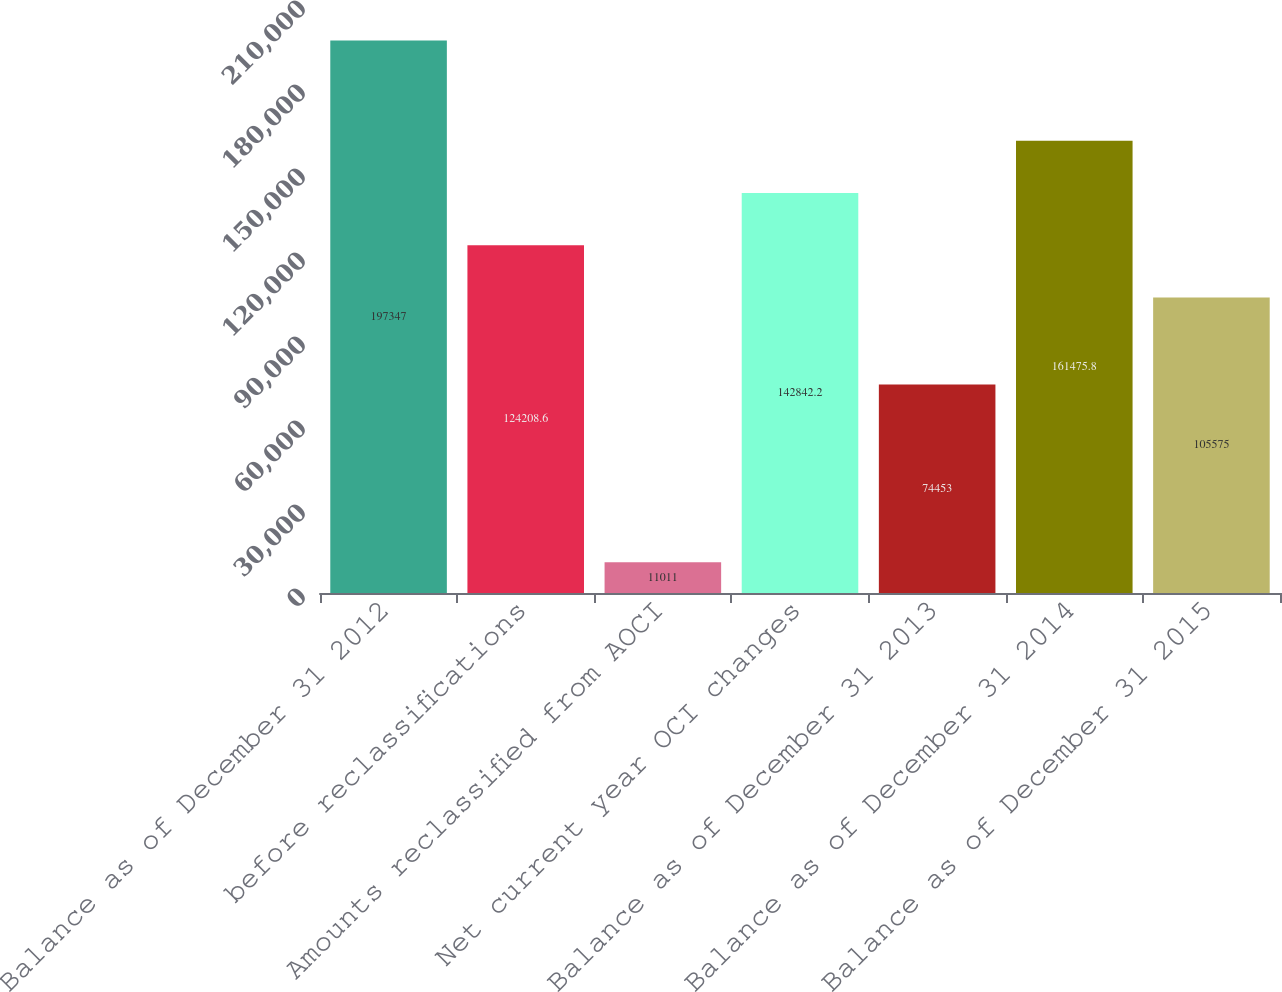Convert chart. <chart><loc_0><loc_0><loc_500><loc_500><bar_chart><fcel>Balance as of December 31 2012<fcel>before reclassifications<fcel>Amounts reclassified from AOCI<fcel>Net current year OCI changes<fcel>Balance as of December 31 2013<fcel>Balance as of December 31 2014<fcel>Balance as of December 31 2015<nl><fcel>197347<fcel>124209<fcel>11011<fcel>142842<fcel>74453<fcel>161476<fcel>105575<nl></chart> 